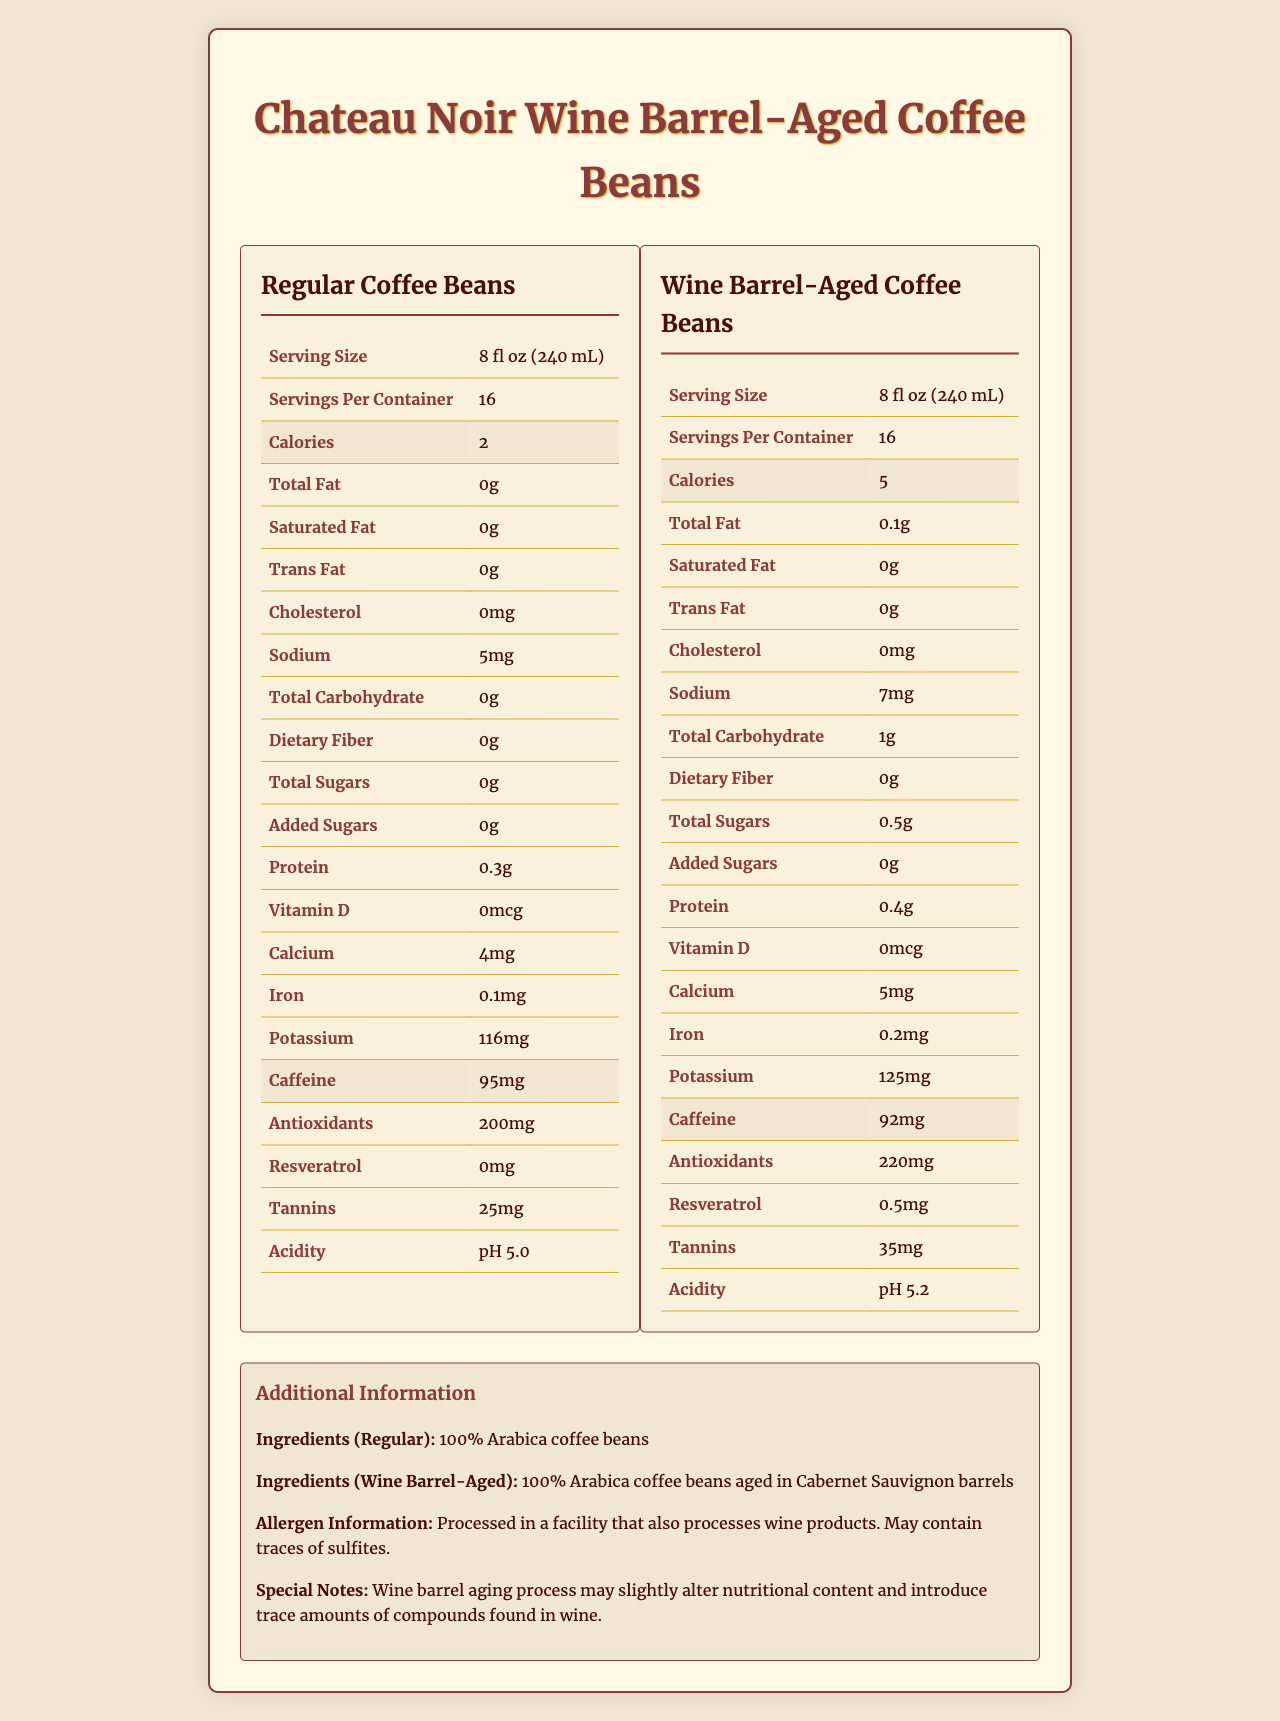what is the serving size for both regular and wine barrel-aged coffee beans? Both regular and wine barrel-aged coffee beans have a serving size of 8 fl oz (240 mL).
Answer: 8 fl oz (240 mL) how many calories per serving does the wine barrel-aged coffee have? The document shows that wine barrel-aged coffee beans have 5 calories per serving.
Answer: 5 what is the amount of potassium in wine barrel-aged coffee per serving? The document states that wine barrel-aged coffee beans contain 125mg of potassium per serving.
Answer: 125mg how much iron is in a serving of regular coffee beans? The nutrition facts list that regular coffee beans have 0.1mg of iron per serving.
Answer: 0.1mg what are the ingredients for wine barrel-aged coffee beans? The document specifies the ingredients for wine barrel-aged coffee beans as "100% Arabica coffee beans aged in Cabernet Sauvignon barrels."
Answer: 100% Arabica coffee beans aged in Cabernet Sauvignon barrels which coffee type has more antioxidants per serving? A. Regular Coffee B. Wine Barrel-Aged Coffee The wine barrel-aged coffee beans have 220mg of antioxidants per serving compared to 200mg in regular coffee beans.
Answer: B what is the difference in sodium content between regular and wine barrel-aged coffee beans? A. 1 mg B. 2 mg C. 5 mg D. 10 mg Regular coffee beans have 5mg of sodium per serving, while wine barrel-aged coffee beans have 7mg, making the difference 2mg.
Answer: B how much caffeine is there in a serving of wine barrel-aged coffee beans? A. 92mg B. 95mg C. 100mg D. 105mg Wine barrel-aged coffee beans have 92mg of caffeine per serving.
Answer: A is there any resveratrol in regular coffee beans? The document shows that regular coffee beans contain 0mg of resveratrol.
Answer: No does wine barrel aging increase the calorie content of coffee beans? The calories per serving in wine barrel-aged coffee beans are higher (5 calories) compared to regular coffee beans (2 calories).
Answer: Yes summarize the main differences between regular and wine barrel-aged coffee beans The document shows a comparative analysis of the nutritional facts between the regular and wine barrel-aged coffee beans, highlighting that wine barrel aging introduces additional nutritional elements and slight increases in several nutritional values.
Answer: Regular coffee and wine barrel-aged coffee beans have differences in nutritional content. Wine barrel-aged coffee beans contain slightly more calories, fat, sodium, carbohydrates, sugars, protein, calcium, iron, potassium, antioxidants, resveratrol, tannins, and have a slightly higher pH value. The ingredients also differ, with wine barrel-aged coffee beans being aged in Cabernet Sauvignon barrels. what is the total carbohydrate content in regular coffee beans? The document does specify the carbohydrate content for regular coffee beans, but this question involves a little trick in phrasing, going beyond simply reading the value. Total carbohydrate is listed as	0g, but the term "total carbohydrate content" could mislead some.
Answer: Cannot be determined what allergen information is given for both types of coffee beans? The document contains a note on allergenic substances, specifying that the coffee beans are processed in a facility dealing with wine products and may contain traces of sulfites.
Answer: Processed in a facility that also processes wine products. May contain traces of sulfites. 